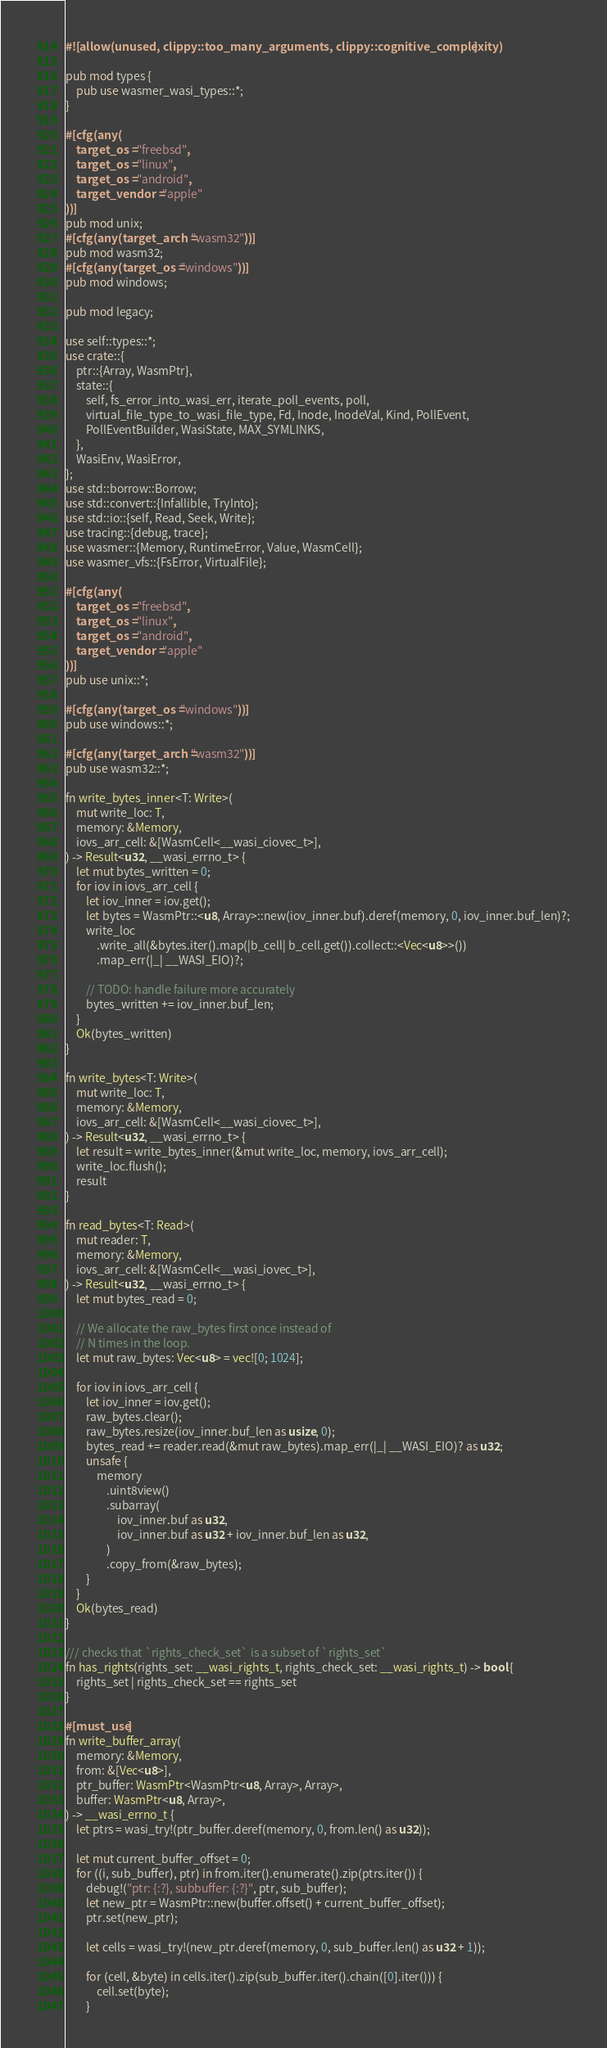<code> <loc_0><loc_0><loc_500><loc_500><_Rust_>#![allow(unused, clippy::too_many_arguments, clippy::cognitive_complexity)]

pub mod types {
    pub use wasmer_wasi_types::*;
}

#[cfg(any(
    target_os = "freebsd",
    target_os = "linux",
    target_os = "android",
    target_vendor = "apple"
))]
pub mod unix;
#[cfg(any(target_arch = "wasm32"))]
pub mod wasm32;
#[cfg(any(target_os = "windows"))]
pub mod windows;

pub mod legacy;

use self::types::*;
use crate::{
    ptr::{Array, WasmPtr},
    state::{
        self, fs_error_into_wasi_err, iterate_poll_events, poll,
        virtual_file_type_to_wasi_file_type, Fd, Inode, InodeVal, Kind, PollEvent,
        PollEventBuilder, WasiState, MAX_SYMLINKS,
    },
    WasiEnv, WasiError,
};
use std::borrow::Borrow;
use std::convert::{Infallible, TryInto};
use std::io::{self, Read, Seek, Write};
use tracing::{debug, trace};
use wasmer::{Memory, RuntimeError, Value, WasmCell};
use wasmer_vfs::{FsError, VirtualFile};

#[cfg(any(
    target_os = "freebsd",
    target_os = "linux",
    target_os = "android",
    target_vendor = "apple"
))]
pub use unix::*;

#[cfg(any(target_os = "windows"))]
pub use windows::*;

#[cfg(any(target_arch = "wasm32"))]
pub use wasm32::*;

fn write_bytes_inner<T: Write>(
    mut write_loc: T,
    memory: &Memory,
    iovs_arr_cell: &[WasmCell<__wasi_ciovec_t>],
) -> Result<u32, __wasi_errno_t> {
    let mut bytes_written = 0;
    for iov in iovs_arr_cell {
        let iov_inner = iov.get();
        let bytes = WasmPtr::<u8, Array>::new(iov_inner.buf).deref(memory, 0, iov_inner.buf_len)?;
        write_loc
            .write_all(&bytes.iter().map(|b_cell| b_cell.get()).collect::<Vec<u8>>())
            .map_err(|_| __WASI_EIO)?;

        // TODO: handle failure more accurately
        bytes_written += iov_inner.buf_len;
    }
    Ok(bytes_written)
}

fn write_bytes<T: Write>(
    mut write_loc: T,
    memory: &Memory,
    iovs_arr_cell: &[WasmCell<__wasi_ciovec_t>],
) -> Result<u32, __wasi_errno_t> {
    let result = write_bytes_inner(&mut write_loc, memory, iovs_arr_cell);
    write_loc.flush();
    result
}

fn read_bytes<T: Read>(
    mut reader: T,
    memory: &Memory,
    iovs_arr_cell: &[WasmCell<__wasi_iovec_t>],
) -> Result<u32, __wasi_errno_t> {
    let mut bytes_read = 0;

    // We allocate the raw_bytes first once instead of
    // N times in the loop.
    let mut raw_bytes: Vec<u8> = vec![0; 1024];

    for iov in iovs_arr_cell {
        let iov_inner = iov.get();
        raw_bytes.clear();
        raw_bytes.resize(iov_inner.buf_len as usize, 0);
        bytes_read += reader.read(&mut raw_bytes).map_err(|_| __WASI_EIO)? as u32;
        unsafe {
            memory
                .uint8view()
                .subarray(
                    iov_inner.buf as u32,
                    iov_inner.buf as u32 + iov_inner.buf_len as u32,
                )
                .copy_from(&raw_bytes);
        }
    }
    Ok(bytes_read)
}

/// checks that `rights_check_set` is a subset of `rights_set`
fn has_rights(rights_set: __wasi_rights_t, rights_check_set: __wasi_rights_t) -> bool {
    rights_set | rights_check_set == rights_set
}

#[must_use]
fn write_buffer_array(
    memory: &Memory,
    from: &[Vec<u8>],
    ptr_buffer: WasmPtr<WasmPtr<u8, Array>, Array>,
    buffer: WasmPtr<u8, Array>,
) -> __wasi_errno_t {
    let ptrs = wasi_try!(ptr_buffer.deref(memory, 0, from.len() as u32));

    let mut current_buffer_offset = 0;
    for ((i, sub_buffer), ptr) in from.iter().enumerate().zip(ptrs.iter()) {
        debug!("ptr: {:?}, subbuffer: {:?}", ptr, sub_buffer);
        let new_ptr = WasmPtr::new(buffer.offset() + current_buffer_offset);
        ptr.set(new_ptr);

        let cells = wasi_try!(new_ptr.deref(memory, 0, sub_buffer.len() as u32 + 1));

        for (cell, &byte) in cells.iter().zip(sub_buffer.iter().chain([0].iter())) {
            cell.set(byte);
        }</code> 